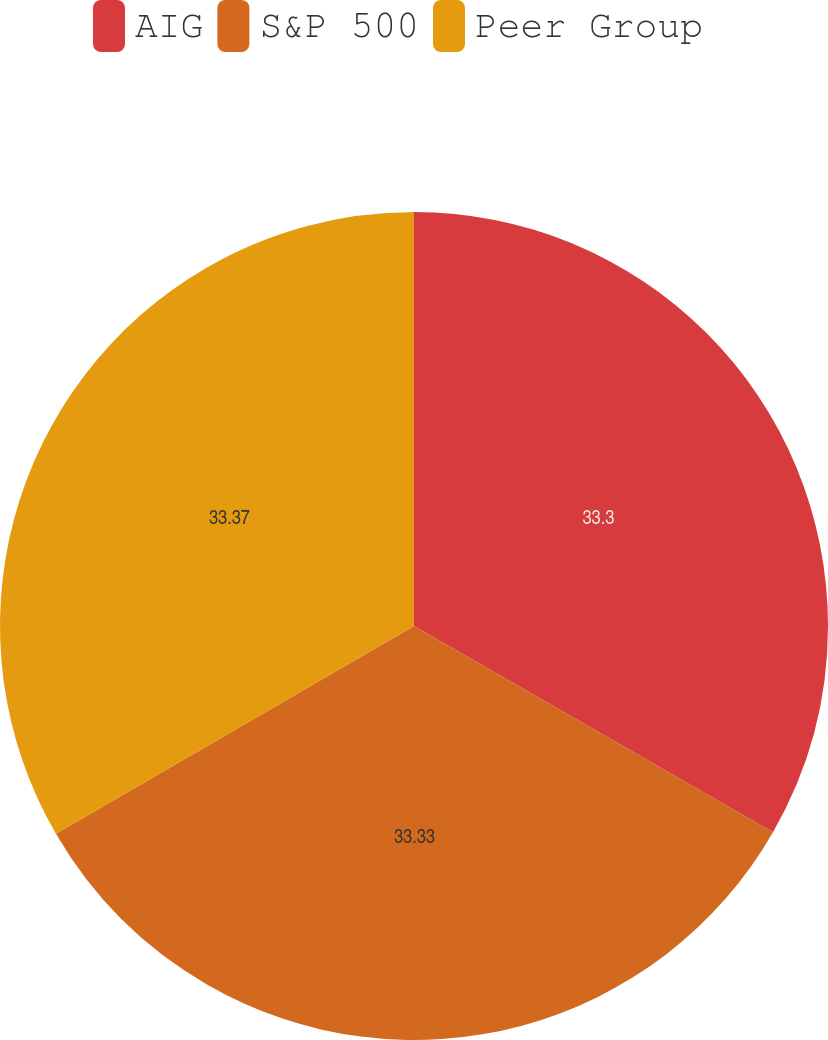Convert chart. <chart><loc_0><loc_0><loc_500><loc_500><pie_chart><fcel>AIG<fcel>S&P 500<fcel>Peer Group<nl><fcel>33.3%<fcel>33.33%<fcel>33.37%<nl></chart> 